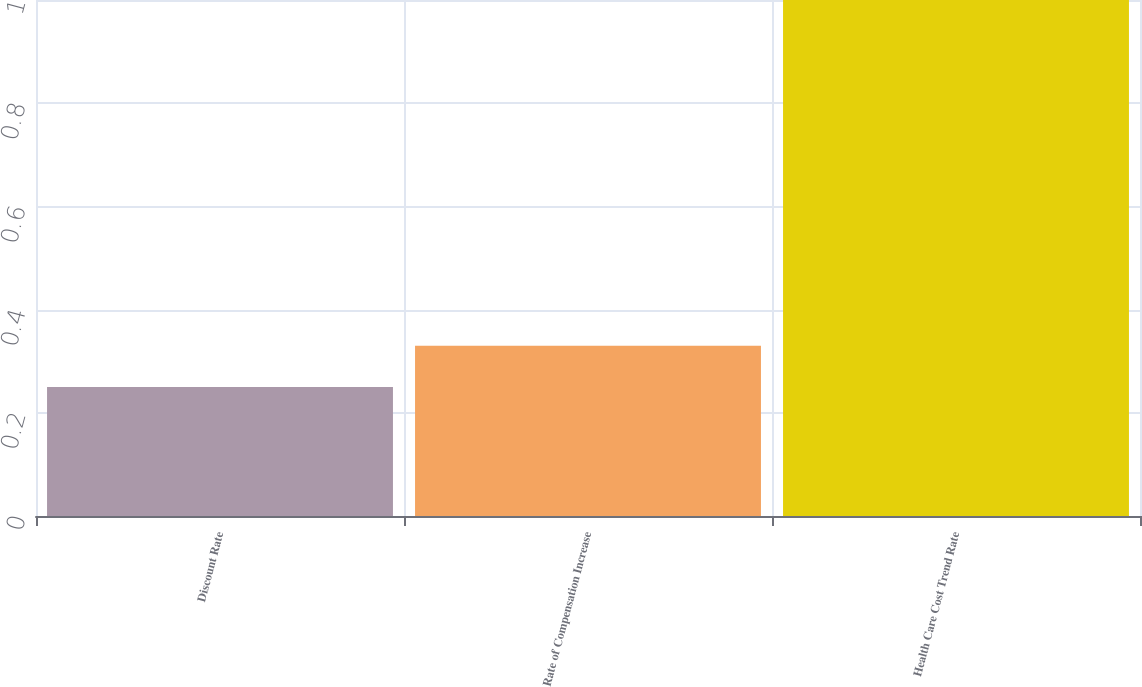Convert chart to OTSL. <chart><loc_0><loc_0><loc_500><loc_500><bar_chart><fcel>Discount Rate<fcel>Rate of Compensation Increase<fcel>Health Care Cost Trend Rate<nl><fcel>0.25<fcel>0.33<fcel>1<nl></chart> 